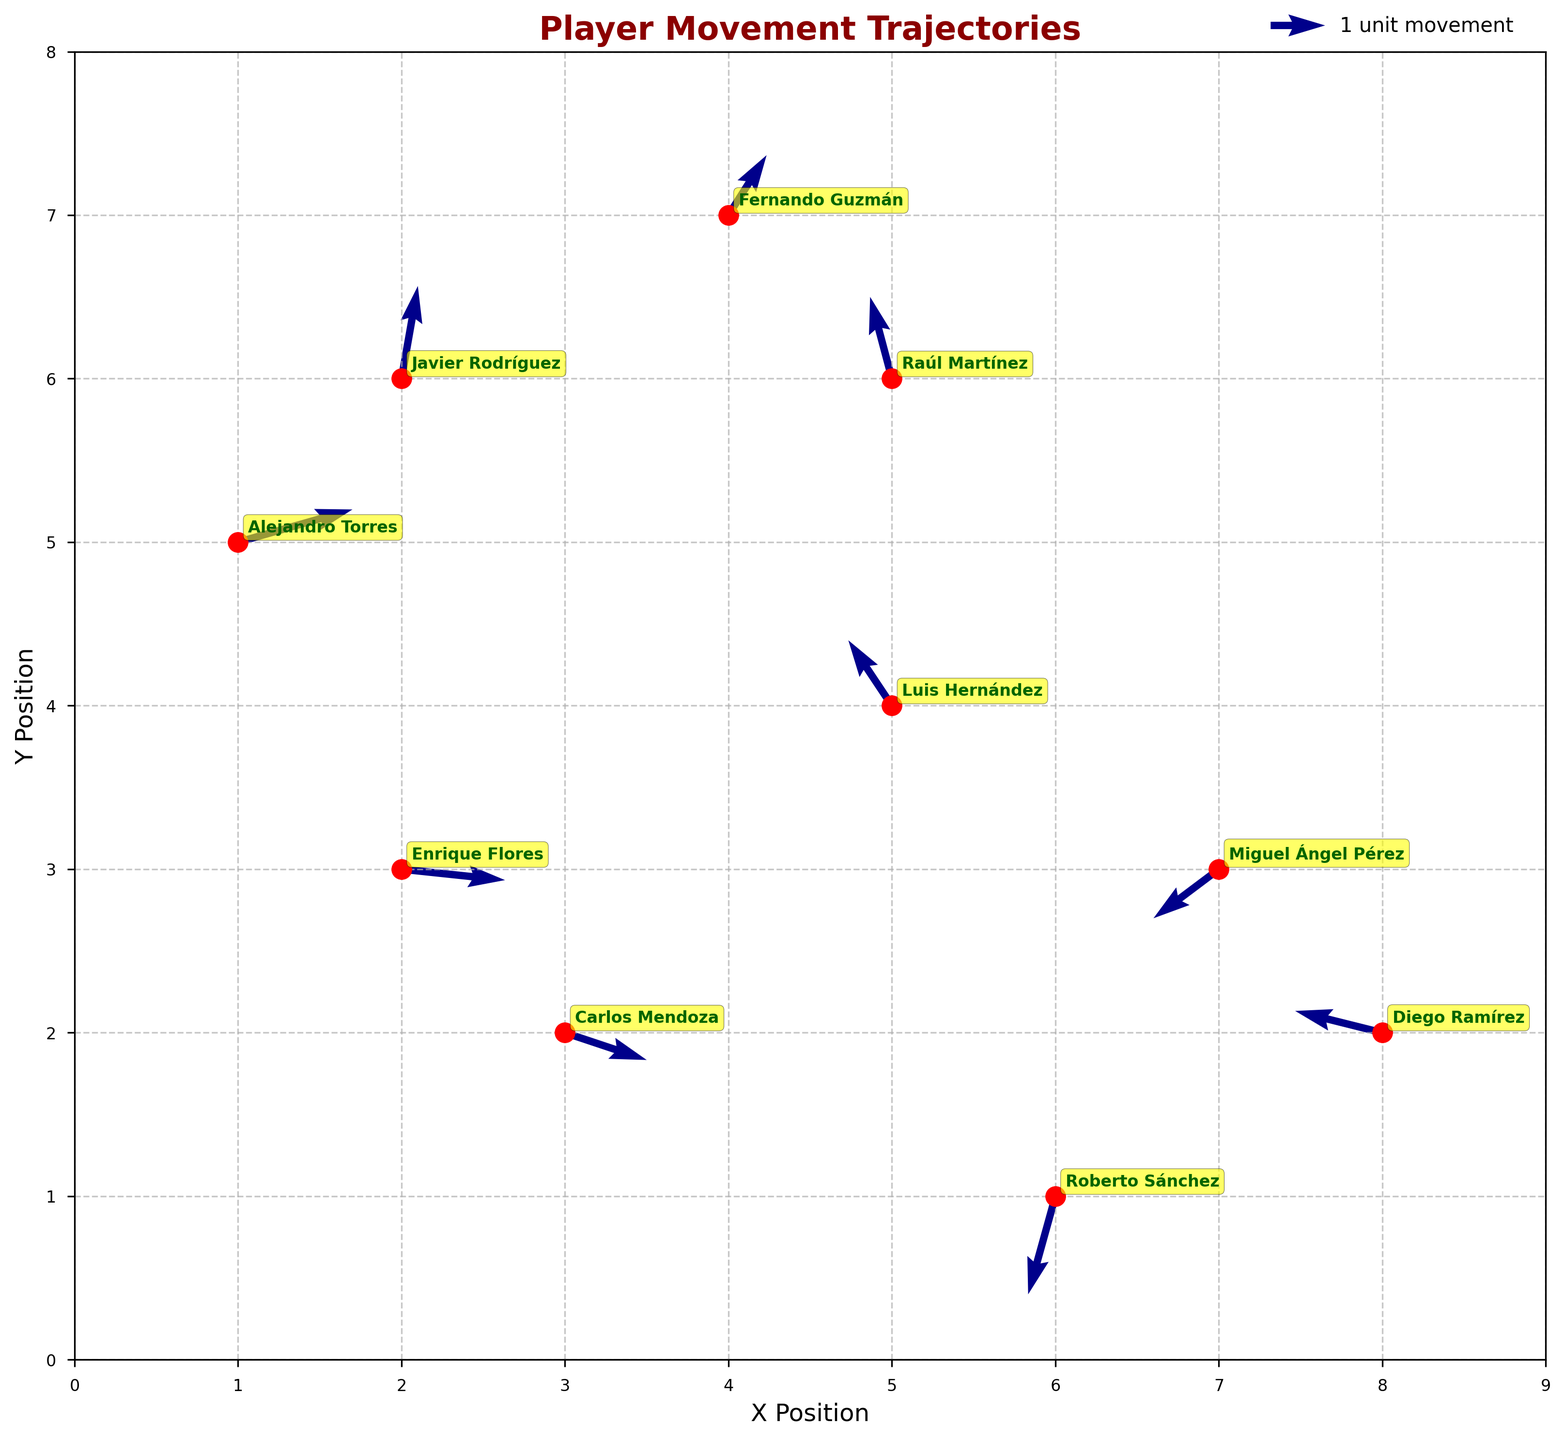How many players' movement trajectories are depicted in the plot? Count the number of unique data points each corresponding to a player. There are 10 points, each labeled with a player's name.
Answer: 10 Which player started closest to the origin (0, 0)? Find the player with coordinates closest to (0, 0). Enrique Flores at (2, 3) is closest.
Answer: Enrique Flores What is the overall direction of Carlos Mendoza's movement trajectory? Look at the arrow starting at Carlos Mendoza's position (3,2) with direction components (1.5, -0.5). This indicates a general movement towards the right and slightly downward directions.
Answer: Right and Down By how much did Alejandro Torres move on the x-axis? Alejandro Torres starts at (1, 5) and moves with a vector (2.1, 0.6). The movement on the x-axis is simply the x-component, 2.1 units.
Answer: 2.1 units Which player shows the largest upward movement in the y-axis? Look at the v-component of the arrows. Javier Rodríguez has the highest v-component with a value of 1.7 at the point (2,6).
Answer: Javier Rodríguez How does Diego Ramírez's movement compare to Miguel Ángel Pérez's movement in terms of x-direction? Diego Ramirez moves from (8, 2) with an x-component of -1.6, while Miguel Ángel Pérez moves from (7, 3) with an x-component of -1.2. Diego's movement in the x-direction is slightly more negative, indicating he moved more to the left.
Answer: Diego moves more to the left What is the resultant distance travelled by Roberto Sánchez? Roberto Sánchez at (6, 1) moves with vector (-0.5, -1.8). The distance is calculated using the Pythagorean theorem √((-0.5)^2 + (-1.8)^2) = √(0.25 + 3.24) = √3.49 ≈ 1.87 units.
Answer: 1.87 units Compare the movements of Fernando Guzmán and Raúl Martínez. Who moved further? Fernando Guzmán with (0.7, 1.1) and Raúl Martínez with (-0.4, 1.5). Calculating the distance, √(0.7^2 + 1.1^2) ≈ 1.3 for Fernando, and √(-0.4^2 + 1.5^2) ≈ 1.55 for Raúl. Raúl Martínez moved further.
Answer: Raúl Martínez Which player has a trajectory that moves predominantly downward? Look for the player with the most negative y-component (v). Miguel Ángel Pérez at (7,3) with vector (-1.2, -0.9) shows a significant downward trend.
Answer: Miguel Ángel Pérez 